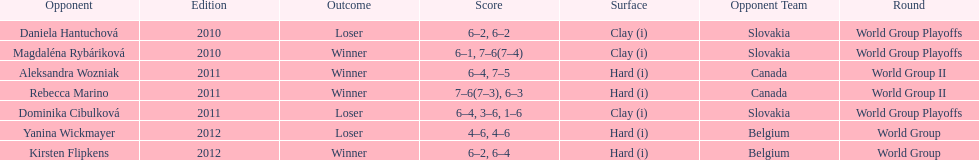What was the next game listed after the world group ii rounds? World Group Playoffs. 